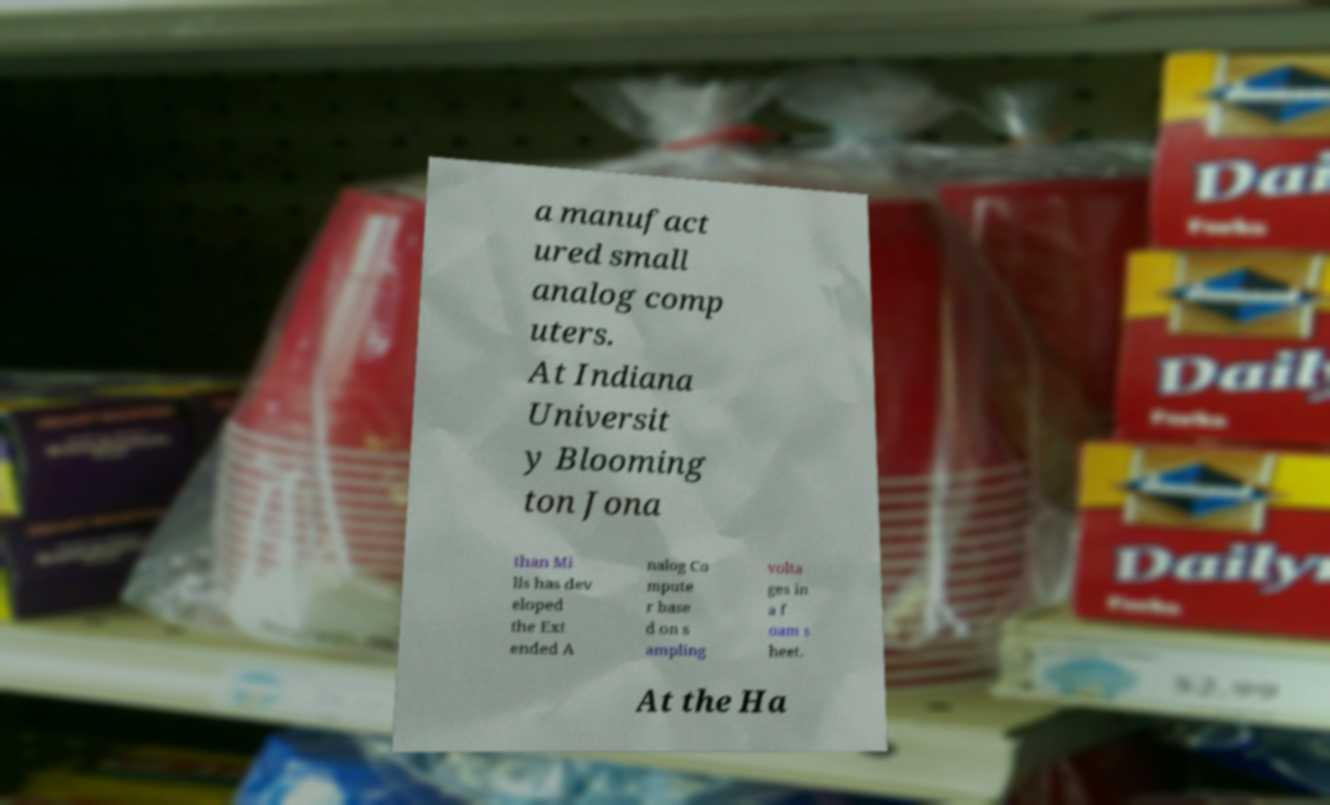For documentation purposes, I need the text within this image transcribed. Could you provide that? a manufact ured small analog comp uters. At Indiana Universit y Blooming ton Jona than Mi lls has dev eloped the Ext ended A nalog Co mpute r base d on s ampling volta ges in a f oam s heet. At the Ha 